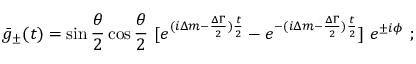<formula> <loc_0><loc_0><loc_500><loc_500>\bar { g } _ { \pm } ( t ) = \sin { \frac { \theta } { 2 } } \cos { \frac { \theta } { 2 } } \ [ e ^ { ( i \Delta m - { \frac { \Delta \Gamma } { 2 } } ) { \frac { t } { 2 } } } - e ^ { - ( i \Delta m - { \frac { \Delta \Gamma } { 2 } } ) { \frac { t } { 2 } } } ] \ e ^ { \pm i \phi } \ ;</formula> 